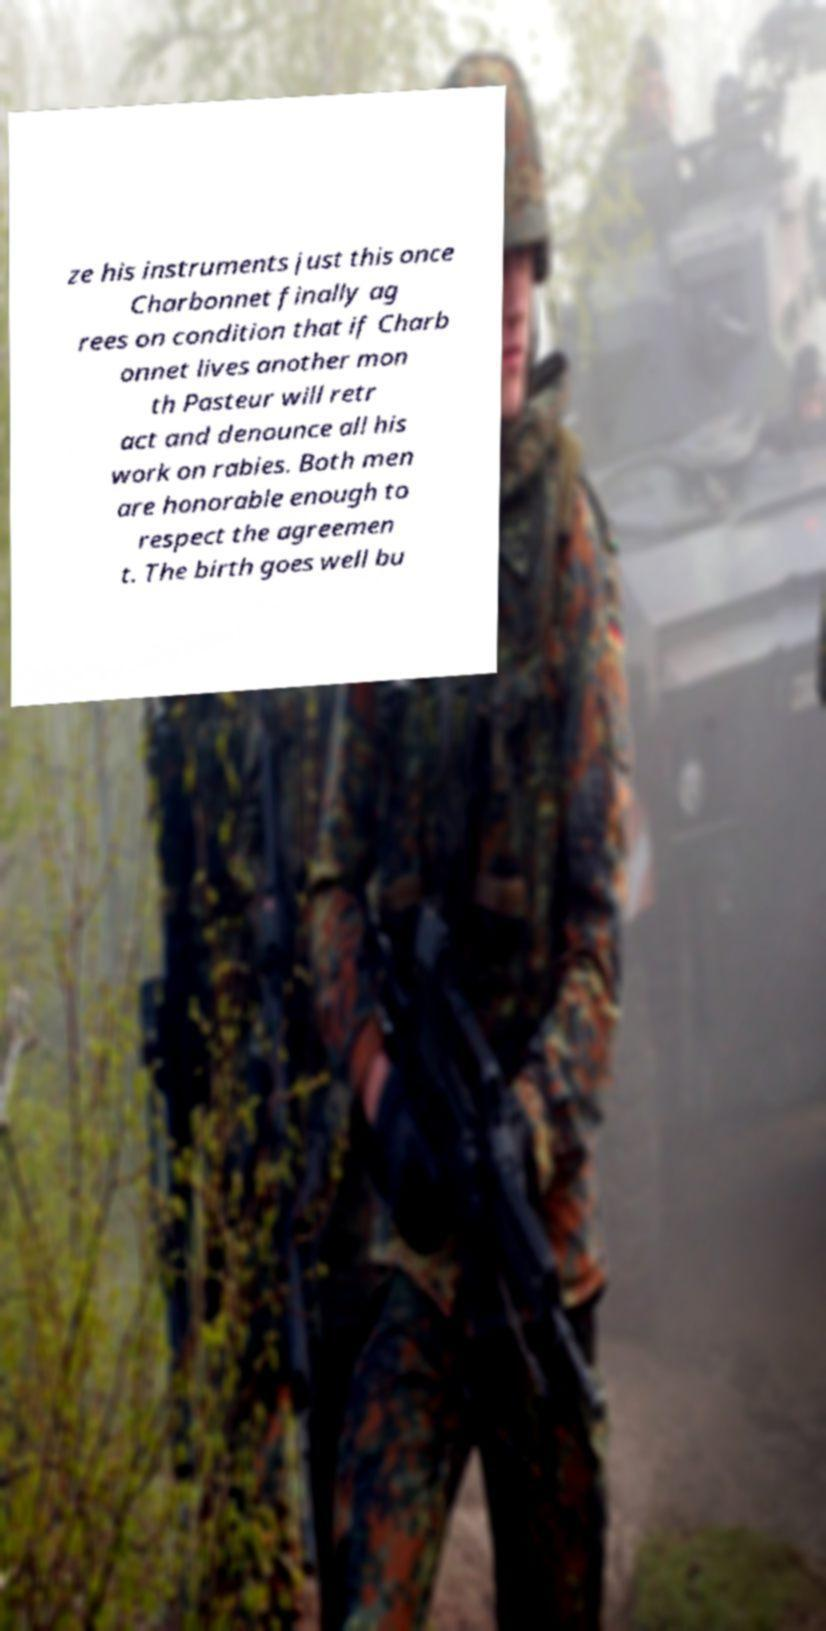There's text embedded in this image that I need extracted. Can you transcribe it verbatim? ze his instruments just this once Charbonnet finally ag rees on condition that if Charb onnet lives another mon th Pasteur will retr act and denounce all his work on rabies. Both men are honorable enough to respect the agreemen t. The birth goes well bu 